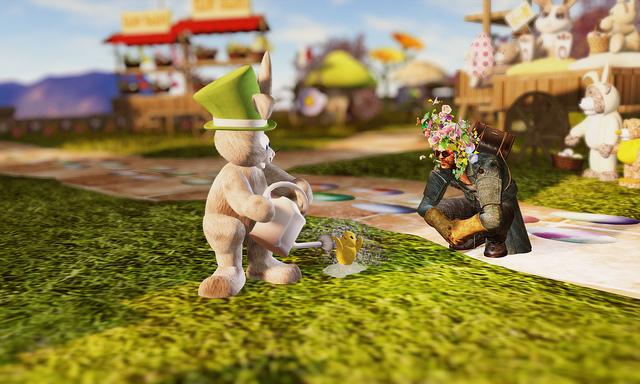Are there stuff animal in the background?
Answer briefly. Yes. What season is it?
Concise answer only. Summer. What type of scene is this?
Answer briefly. Animated. 